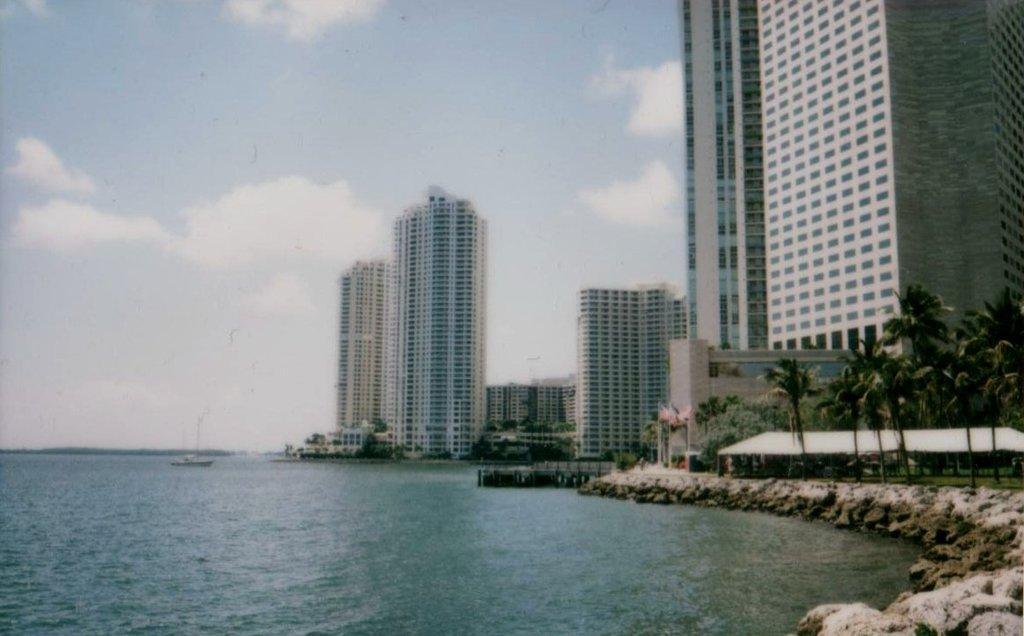Describe this image in one or two sentences. In this image, we can see buildings, trees, hut, stones and plants. At the bottom, we can see a boat sailing on the water. Background there is the sky. 